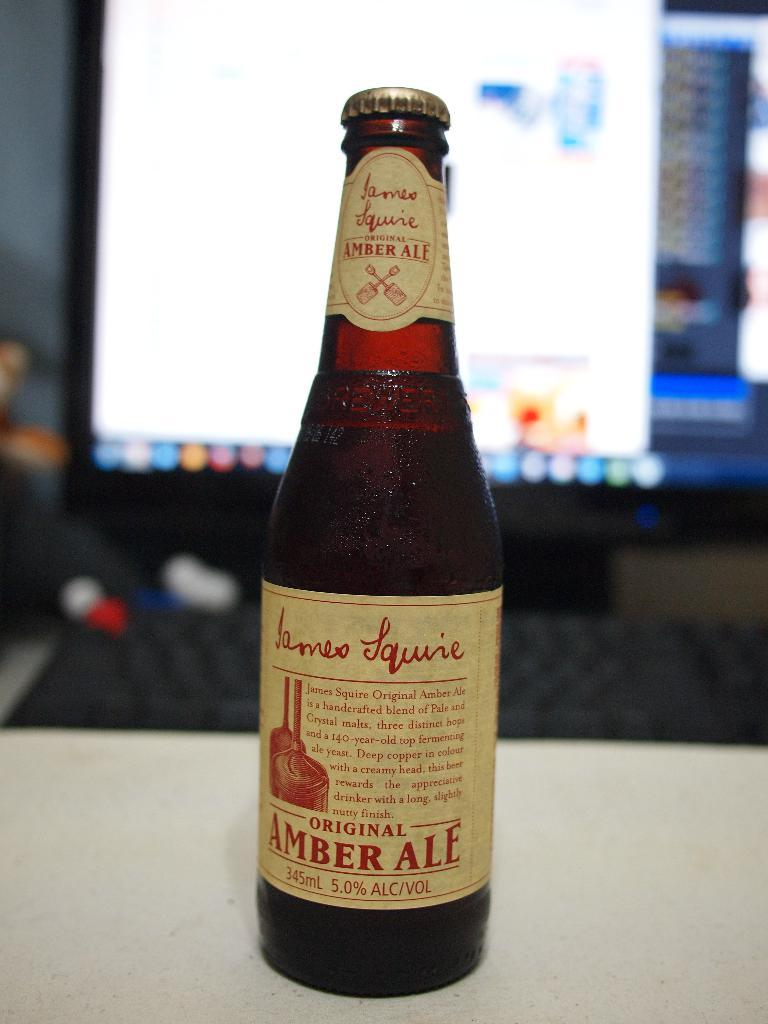What is the main object in the image? There is a wine bottle in the image. Where is the wine bottle located? The wine bottle is placed on a table. What else can be seen in the background of the image? There is a screen visible in the background of the image. What type of fowl can be seen perched on the wine bottle in the image? There is no fowl present on the wine bottle in the image. What kind of bait is used to catch fish in the image? There is no fishing or bait present in the image; it features a wine bottle on a table and a screen in the background. 